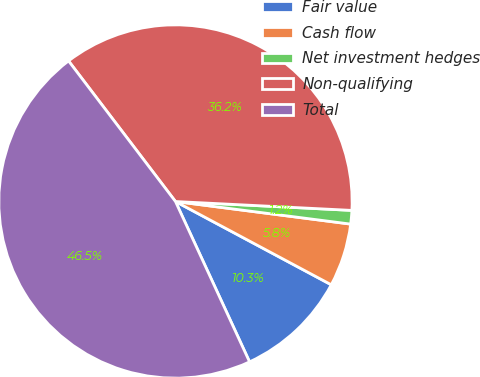<chart> <loc_0><loc_0><loc_500><loc_500><pie_chart><fcel>Fair value<fcel>Cash flow<fcel>Net investment hedges<fcel>Non-qualifying<fcel>Total<nl><fcel>10.3%<fcel>5.77%<fcel>1.24%<fcel>36.15%<fcel>46.54%<nl></chart> 